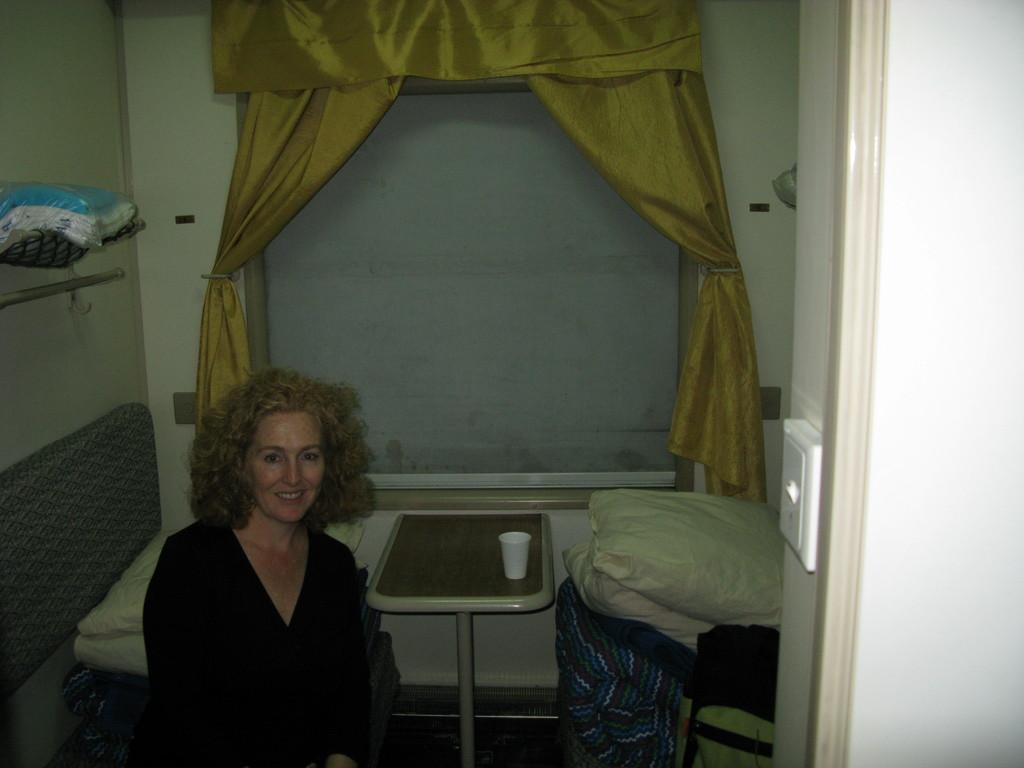Please provide a concise description of this image. This image consists of chairs, pillows, and table. On that table there is a glass. There is a person sitting on the left side. There is a curtain at the top. This looks like a train. 